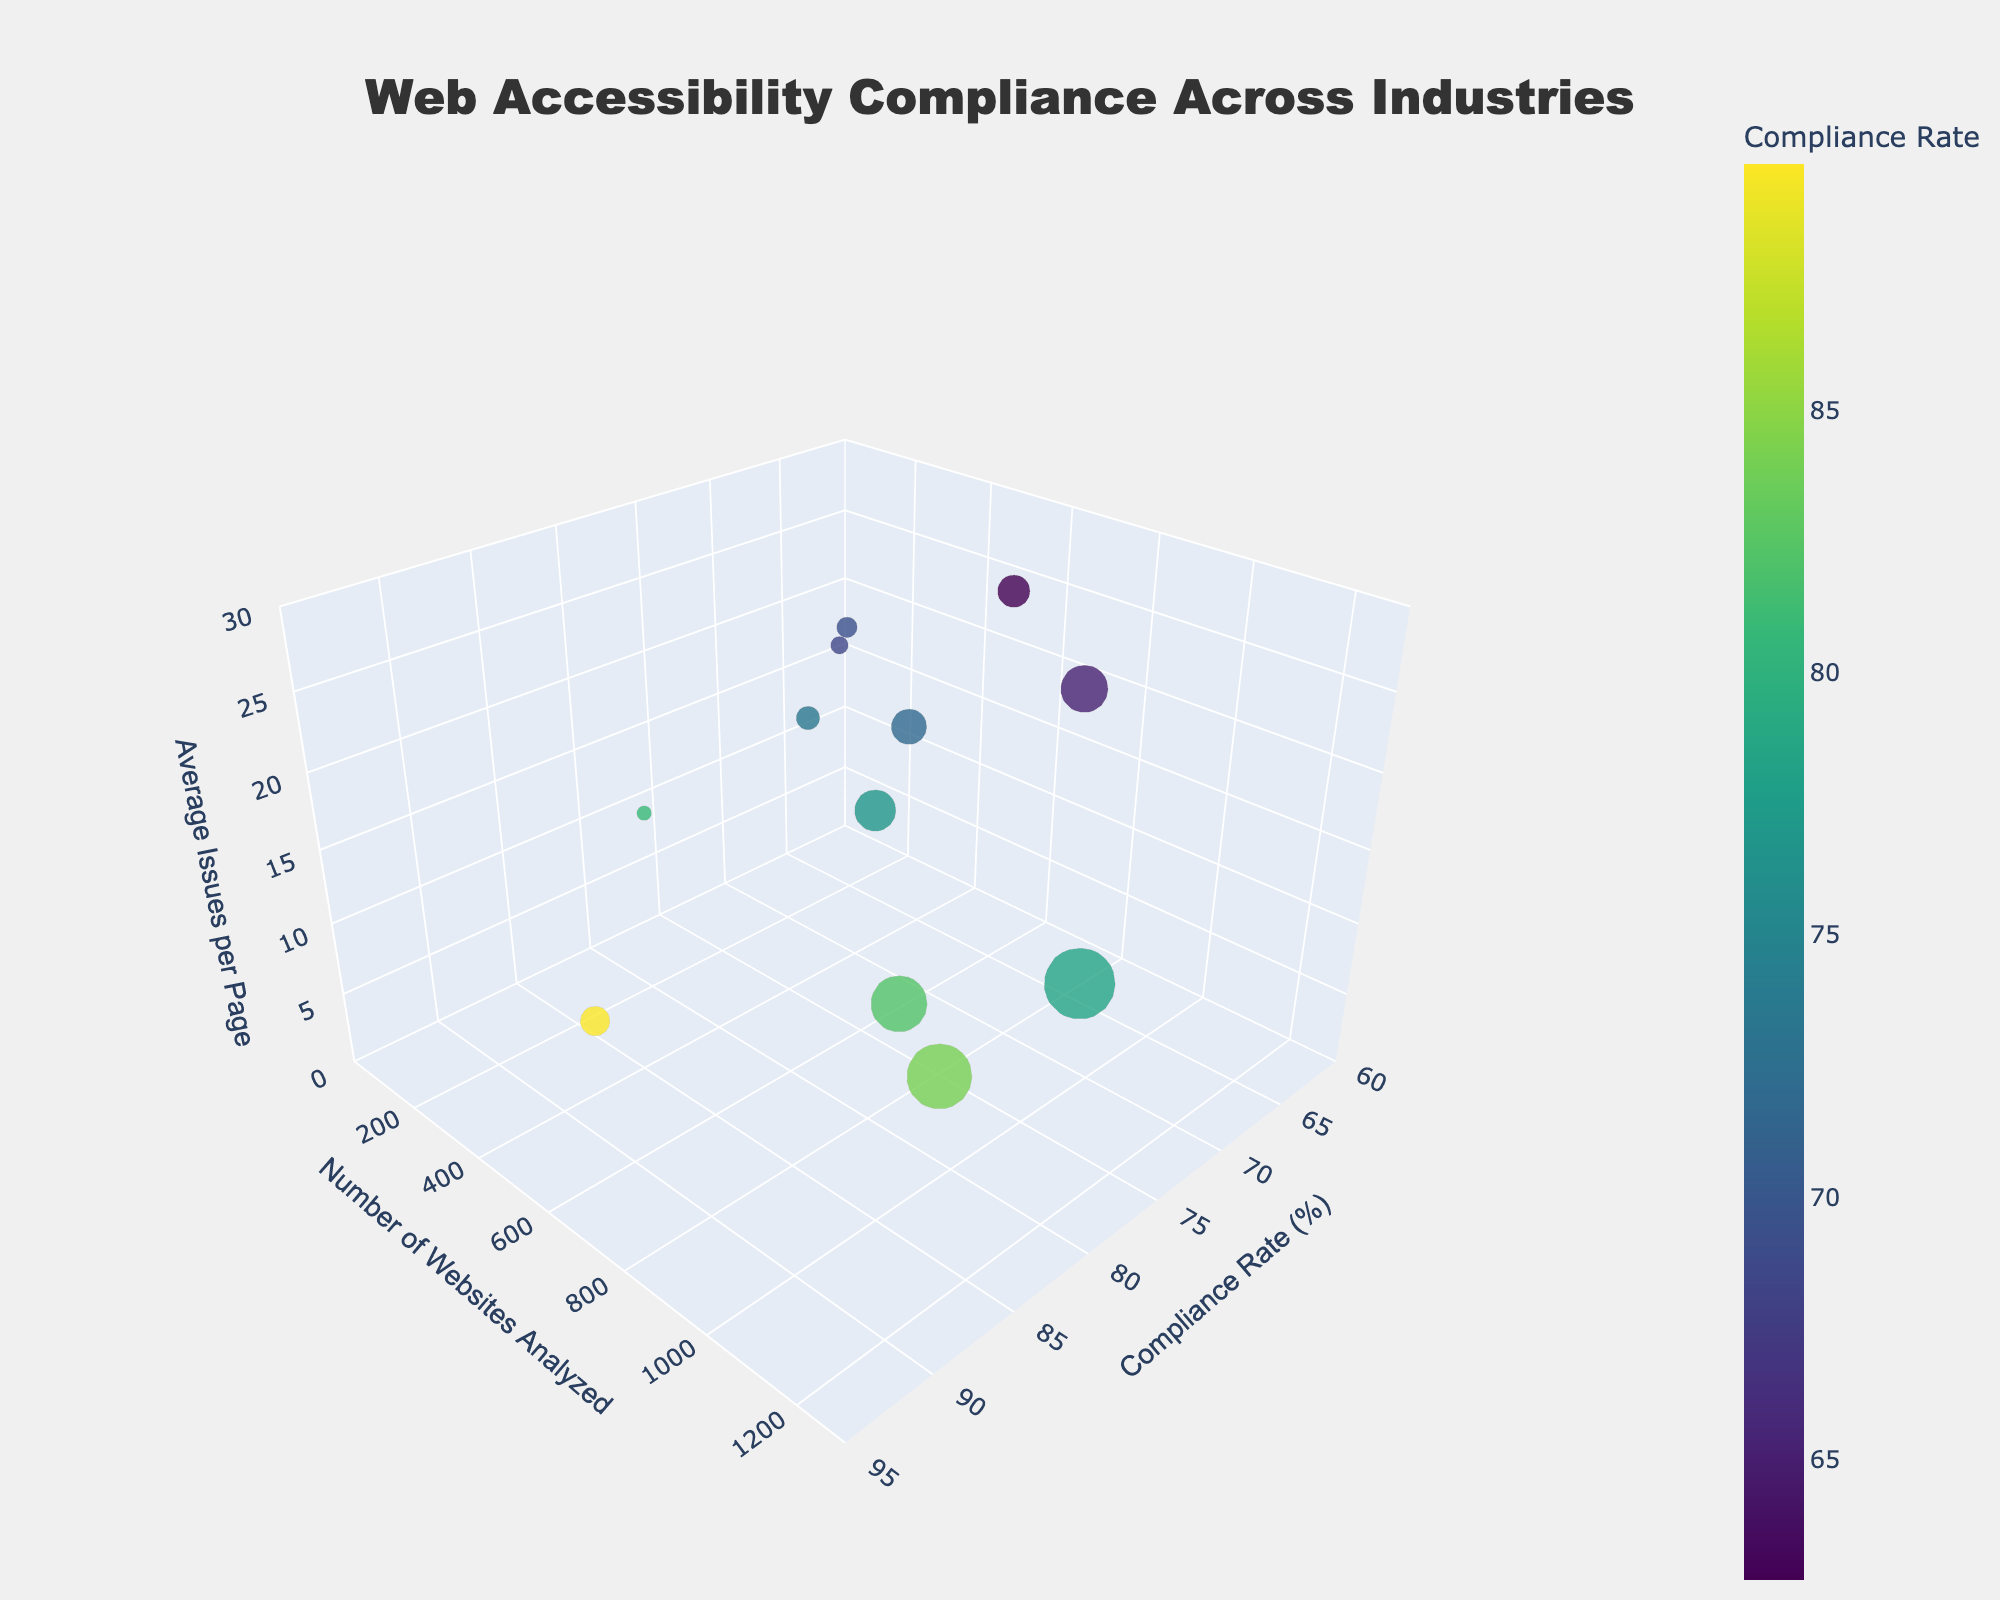What's the title of the chart? The title is displayed at the top and centered. Since this identifies the main topic, it reads "Web Accessibility Compliance Across Industries."
Answer: Web Accessibility Compliance Across Industries Which industry has the highest compliance rate? By looking at the x-axis representing compliance rate, you can see that the Federal Agency (Government) bubble is furthest to the right, indicating the highest compliance rate.
Answer: Government How many website types are analyzed in the Education industry? There is one bubble in the chart for each industry and matching website type analyzed. For Education, the text states that universities were analyzed, indicating one website type.
Answer: 1 What is the average number of issues per page for Healthcare websites? Locate the Healthcare bubble, then look at the z-axis which represents the average number of issues per page. The value for Healthcare can be identified as 22.
Answer: 22 Which website types have more average issues per page than Online Retail websites? First, note the average issues per page for Online Retail (15). Then, compare other website types (e.g., those in Healthcare, Real Estate, Automotive, etc.) that are positioned higher on the z-axis.
Answer: Hospital, News Portal, Airline, Charity Organization, Property Listing, Car Manufacturer What is the median compliance rate among all industries? Arrange the compliance rates in numerical order [62.7, 65.2, 68.5, 69.3, 71.8, 73.4, 76.9, 78.5, 80.9, 82.3, 84.1, 89.7]. The middle values are 71.8 and 73.4. So, the median is (71.8 + 73.4)/2 = 72.6.
Answer: 72.6 Which industry analyzed the least number of websites? Compare the bubbles along the y-axis representing the number of websites analyzed; the smallest bubble on the y-axis refers to Entertainment (250 websites).
Answer: Entertainment Compare the compliance rate between Bank and SaaS Product websites. Which one is higher and by how much? Bank websites have a compliance rate of 76.9 and SaaS Product websites have a compliance rate of 84.1. The difference is 84.1 - 76.9 = 7.2.
Answer: SaaS Product is higher by 7.2 Which industry has the highest average issues per page and how many? By comparing the height of the bubbles on the z-axis, Real Estate (Property Listing) has the highest at 25 average issues per page.
Answer: Real Estate, 25 How does the compliance rate of Charity Organization websites compare to Car Manufacturer websites? Charity Organization has a compliance rate of 68.5 and Car Manufacturer has 69.3. Charity Organization's rate is lower.
Answer: Charity Organization is lower than Car Manufacturer 